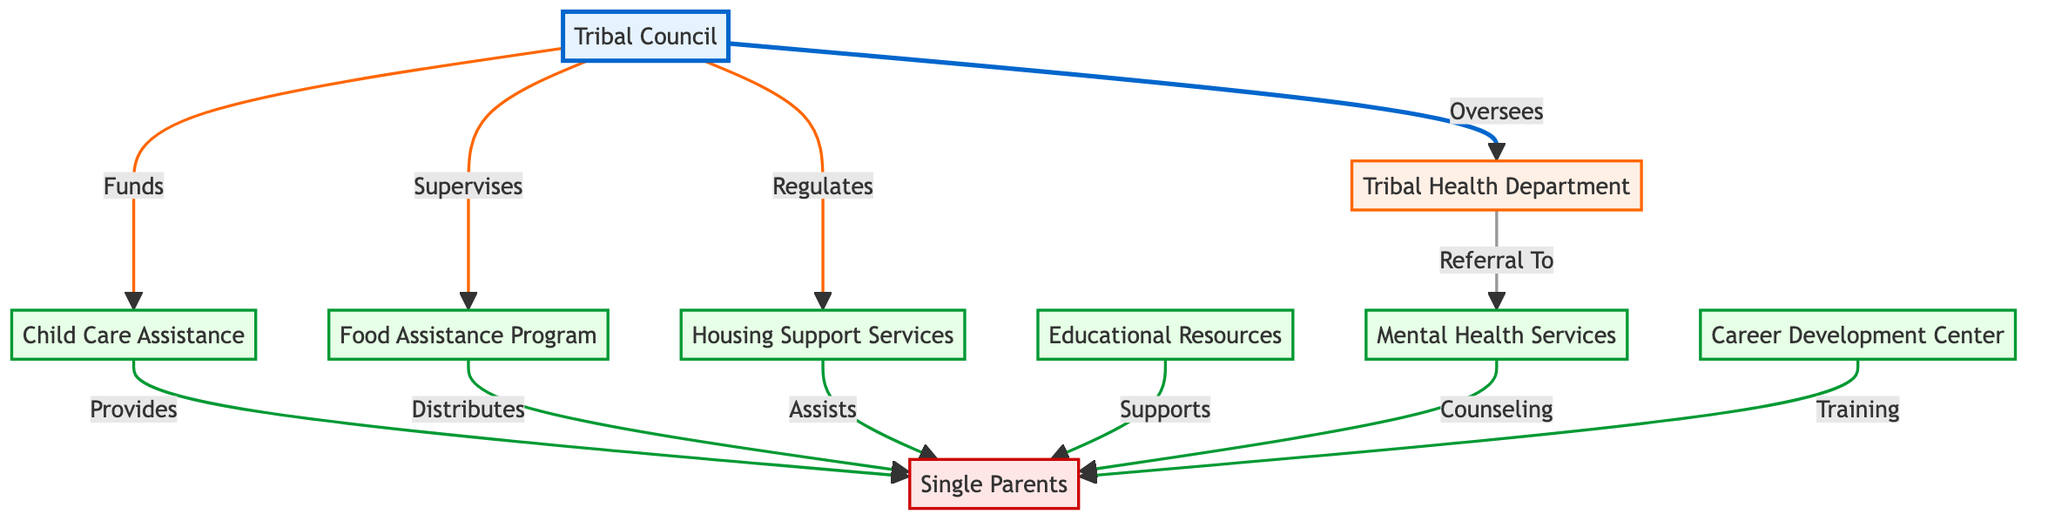What is the title of the first node? The first node in the diagram is labeled "Tribal Council", which serves as the oversight authority for the other services.
Answer: Tribal Council How many service nodes are there in total? The diagram lists five service nodes: Child Care Assistance, Food Assistance Program, Housing Support Services, Educational Resources, and Mental Health Services. Counting them gives a total of five service nodes.
Answer: 5 Which department oversees the Child Care Assistance program? According to the diagram, the Tribal Council oversees the Child Care Assistance program, indicating its direct supervisory role over this service.
Answer: Tribal Council What type of service does the Career Development Center provide? The Career Development Center provides training for single parents, as indicated in the diagram that connects it to the recipient node labeled "Single Parents".
Answer: Training Which service is referred to by the Tribal Health Department? The Tribal Health Department is connected to Mental Health Services in the diagram, indicating that it refers single parents to this particular service for their mental health needs.
Answer: Mental Health Services How does the Tribal Council fund the services? The Tribal Council is shown to fund the Child Care Assistance program, establishing a financial relationship with this specific service among others it oversees.
Answer: Funds Which node is the direct recipient of the Food Assistance Program? The diagram indicates that the Food Assistance Program distributes resources directly to the node labeled "Single Parents", making them the intended beneficiaries of this service.
Answer: Single Parents Identify the relationship between the Tribal Health Department and Mental Health Services. The Tribal Health Department has a linking path labeled "Referral To" that connects it to Mental Health Services, indicating that it refers individuals to this service for support.
Answer: Referral To What role does the Tribal Council have in relation to Housing Support Services? The Tribal Council is shown as regulating the Housing Support Services, reflecting its governance function over this service for better management and oversight.
Answer: Regulates 